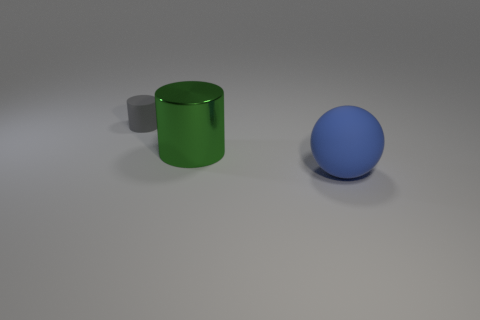What color is the metal thing?
Your answer should be compact. Green. How many tiny objects are either blue rubber spheres or metallic cubes?
Provide a succinct answer. 0. Is the color of the cylinder that is behind the green cylinder the same as the large thing behind the big ball?
Make the answer very short. No. What number of other things are the same color as the big sphere?
Ensure brevity in your answer.  0. What shape is the matte thing in front of the gray matte thing?
Give a very brief answer. Sphere. Is the number of cylinders less than the number of gray matte cylinders?
Provide a succinct answer. No. Does the object in front of the big cylinder have the same material as the large cylinder?
Keep it short and to the point. No. Is there anything else that has the same size as the sphere?
Provide a succinct answer. Yes. Are there any large cylinders right of the matte sphere?
Offer a terse response. No. What color is the rubber object in front of the rubber object left of the matte thing that is in front of the gray cylinder?
Ensure brevity in your answer.  Blue. 